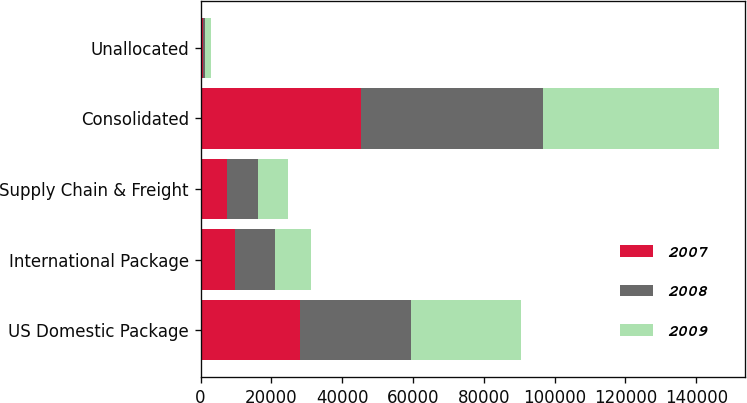Convert chart. <chart><loc_0><loc_0><loc_500><loc_500><stacked_bar_chart><ecel><fcel>US Domestic Package<fcel>International Package<fcel>Supply Chain & Freight<fcel>Consolidated<fcel>Unallocated<nl><fcel>2007<fcel>28158<fcel>9699<fcel>7440<fcel>45297<fcel>809<nl><fcel>2008<fcel>31278<fcel>11293<fcel>8915<fcel>51486<fcel>585<nl><fcel>2009<fcel>30985<fcel>10281<fcel>8426<fcel>49692<fcel>1686<nl></chart> 